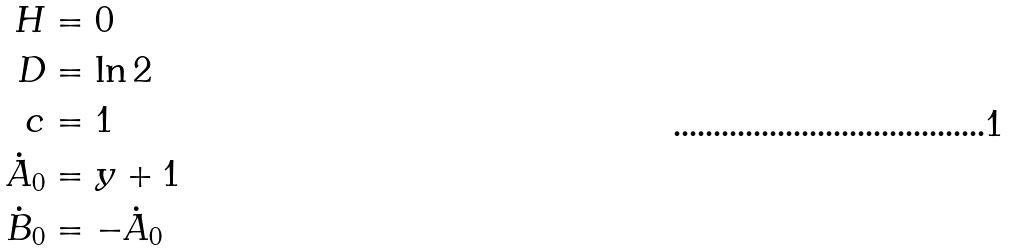Convert formula to latex. <formula><loc_0><loc_0><loc_500><loc_500>H & = 0 \\ D & = \ln 2 \\ c & = 1 \\ \dot { A } _ { 0 } & = y + 1 \\ \dot { B } _ { 0 } & = - \dot { A } _ { 0 }</formula> 